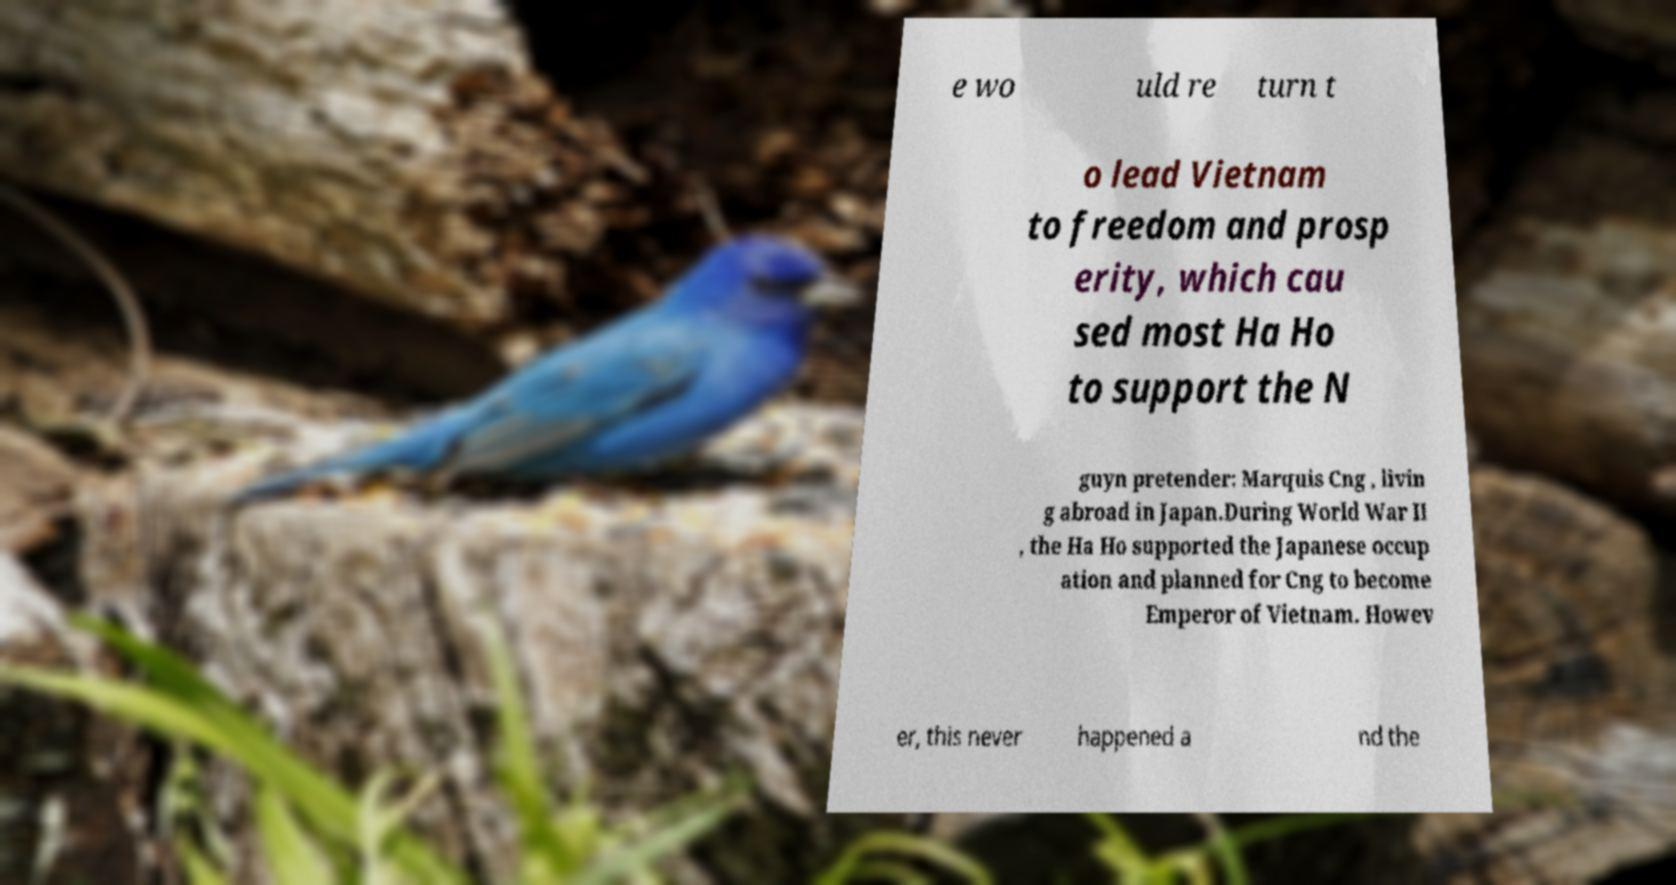Could you extract and type out the text from this image? e wo uld re turn t o lead Vietnam to freedom and prosp erity, which cau sed most Ha Ho to support the N guyn pretender: Marquis Cng , livin g abroad in Japan.During World War II , the Ha Ho supported the Japanese occup ation and planned for Cng to become Emperor of Vietnam. Howev er, this never happened a nd the 